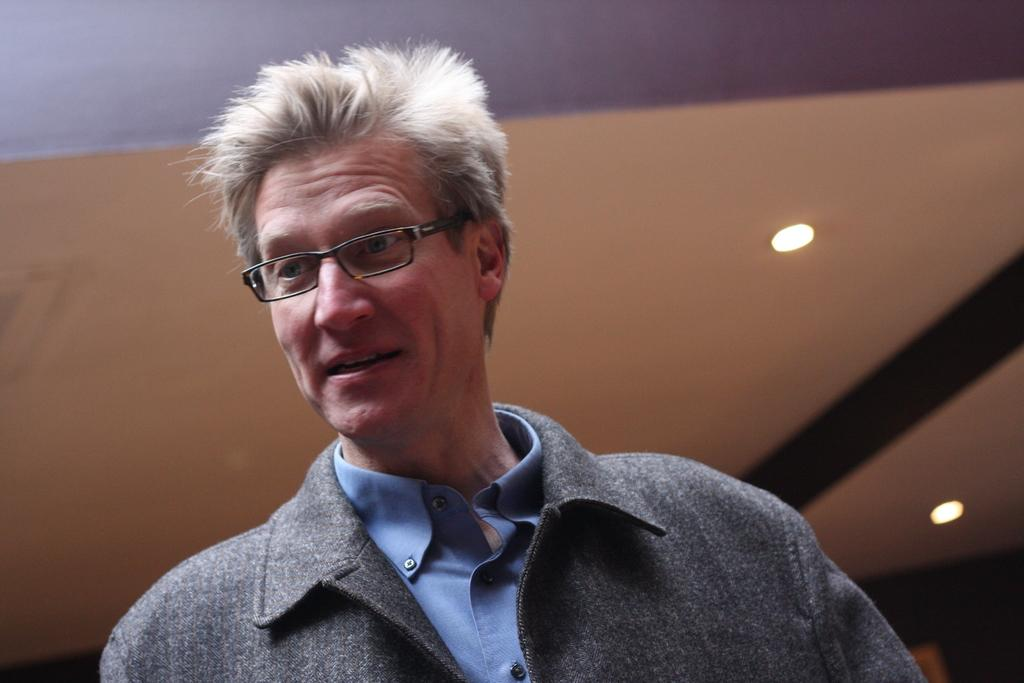Who is present in the image? There is a man in the image. What is the man doing in the image? The man is smiling in the image. What accessory is the man wearing in the image? The man is wearing spectacles in the image. What can be seen in the background of the image? There is a ceiling and lights visible in the background of the image. What verse is the man reciting in the image? There is no verse being recited in the image; the man is simply smiling. What is in the man's pocket in the image? There is no information about the man's pocket in the image, as the focus is on his smile and spectacles. 